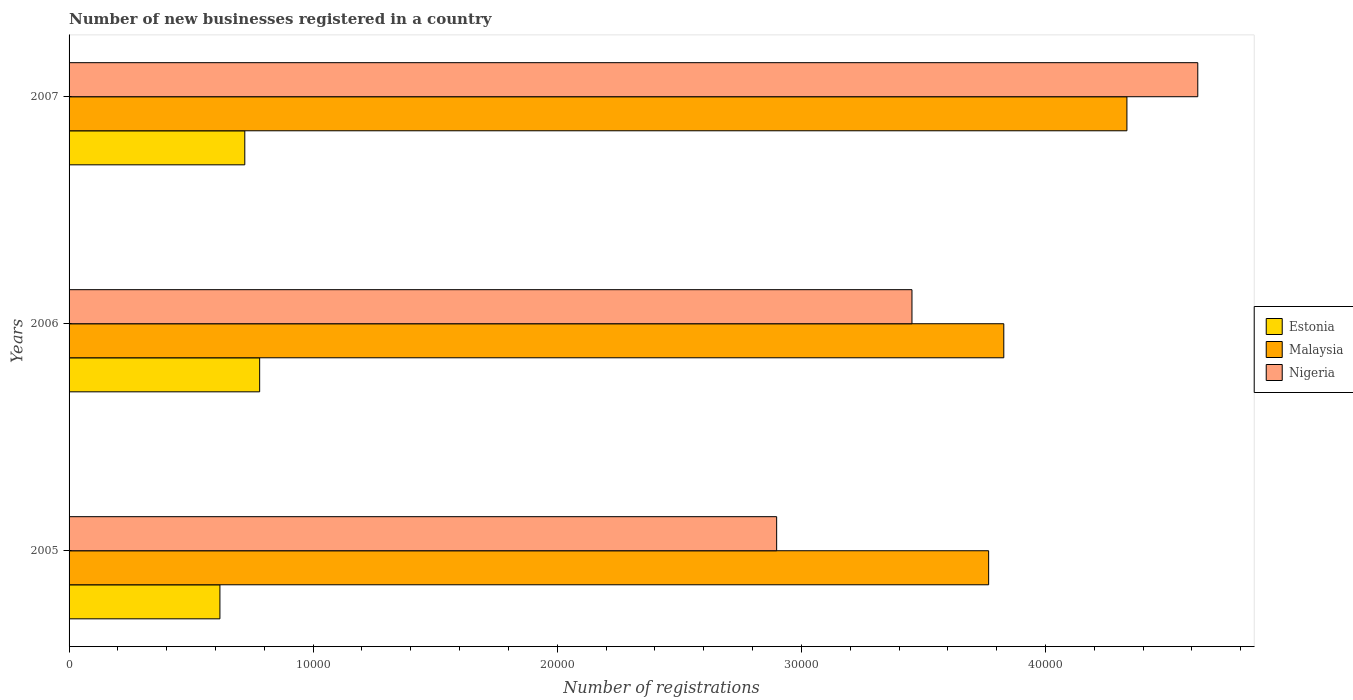What is the label of the 3rd group of bars from the top?
Your response must be concise. 2005. In how many cases, is the number of bars for a given year not equal to the number of legend labels?
Give a very brief answer. 0. What is the number of new businesses registered in Malaysia in 2005?
Offer a terse response. 3.77e+04. Across all years, what is the maximum number of new businesses registered in Nigeria?
Ensure brevity in your answer.  4.62e+04. Across all years, what is the minimum number of new businesses registered in Estonia?
Offer a very short reply. 6180. In which year was the number of new businesses registered in Estonia maximum?
Provide a short and direct response. 2006. In which year was the number of new businesses registered in Nigeria minimum?
Ensure brevity in your answer.  2005. What is the total number of new businesses registered in Estonia in the graph?
Ensure brevity in your answer.  2.12e+04. What is the difference between the number of new businesses registered in Malaysia in 2005 and that in 2007?
Ensure brevity in your answer.  -5665. What is the difference between the number of new businesses registered in Nigeria in 2006 and the number of new businesses registered in Estonia in 2005?
Your response must be concise. 2.84e+04. What is the average number of new businesses registered in Nigeria per year?
Provide a short and direct response. 3.66e+04. In the year 2006, what is the difference between the number of new businesses registered in Malaysia and number of new businesses registered in Estonia?
Give a very brief answer. 3.05e+04. In how many years, is the number of new businesses registered in Nigeria greater than 2000 ?
Offer a terse response. 3. What is the ratio of the number of new businesses registered in Estonia in 2005 to that in 2006?
Your answer should be very brief. 0.79. Is the difference between the number of new businesses registered in Malaysia in 2006 and 2007 greater than the difference between the number of new businesses registered in Estonia in 2006 and 2007?
Provide a succinct answer. No. What is the difference between the highest and the second highest number of new businesses registered in Malaysia?
Your answer should be very brief. 5044. What is the difference between the highest and the lowest number of new businesses registered in Malaysia?
Make the answer very short. 5665. What does the 3rd bar from the top in 2005 represents?
Provide a short and direct response. Estonia. What does the 3rd bar from the bottom in 2007 represents?
Your answer should be compact. Nigeria. What is the difference between two consecutive major ticks on the X-axis?
Offer a very short reply. 10000. Where does the legend appear in the graph?
Your answer should be very brief. Center right. What is the title of the graph?
Keep it short and to the point. Number of new businesses registered in a country. What is the label or title of the X-axis?
Your response must be concise. Number of registrations. What is the label or title of the Y-axis?
Your answer should be compact. Years. What is the Number of registrations of Estonia in 2005?
Your response must be concise. 6180. What is the Number of registrations in Malaysia in 2005?
Provide a succinct answer. 3.77e+04. What is the Number of registrations in Nigeria in 2005?
Keep it short and to the point. 2.90e+04. What is the Number of registrations in Estonia in 2006?
Provide a succinct answer. 7808. What is the Number of registrations of Malaysia in 2006?
Your answer should be very brief. 3.83e+04. What is the Number of registrations of Nigeria in 2006?
Offer a terse response. 3.45e+04. What is the Number of registrations in Estonia in 2007?
Provide a short and direct response. 7199. What is the Number of registrations of Malaysia in 2007?
Give a very brief answer. 4.33e+04. What is the Number of registrations of Nigeria in 2007?
Provide a succinct answer. 4.62e+04. Across all years, what is the maximum Number of registrations of Estonia?
Your response must be concise. 7808. Across all years, what is the maximum Number of registrations in Malaysia?
Offer a terse response. 4.33e+04. Across all years, what is the maximum Number of registrations in Nigeria?
Your answer should be compact. 4.62e+04. Across all years, what is the minimum Number of registrations of Estonia?
Offer a very short reply. 6180. Across all years, what is the minimum Number of registrations in Malaysia?
Ensure brevity in your answer.  3.77e+04. Across all years, what is the minimum Number of registrations in Nigeria?
Your answer should be compact. 2.90e+04. What is the total Number of registrations of Estonia in the graph?
Provide a short and direct response. 2.12e+04. What is the total Number of registrations in Malaysia in the graph?
Provide a short and direct response. 1.19e+05. What is the total Number of registrations in Nigeria in the graph?
Keep it short and to the point. 1.10e+05. What is the difference between the Number of registrations in Estonia in 2005 and that in 2006?
Make the answer very short. -1628. What is the difference between the Number of registrations of Malaysia in 2005 and that in 2006?
Provide a short and direct response. -621. What is the difference between the Number of registrations in Nigeria in 2005 and that in 2006?
Your response must be concise. -5543. What is the difference between the Number of registrations of Estonia in 2005 and that in 2007?
Your response must be concise. -1019. What is the difference between the Number of registrations of Malaysia in 2005 and that in 2007?
Ensure brevity in your answer.  -5665. What is the difference between the Number of registrations in Nigeria in 2005 and that in 2007?
Your answer should be compact. -1.73e+04. What is the difference between the Number of registrations of Estonia in 2006 and that in 2007?
Your response must be concise. 609. What is the difference between the Number of registrations of Malaysia in 2006 and that in 2007?
Provide a short and direct response. -5044. What is the difference between the Number of registrations of Nigeria in 2006 and that in 2007?
Give a very brief answer. -1.17e+04. What is the difference between the Number of registrations of Estonia in 2005 and the Number of registrations of Malaysia in 2006?
Ensure brevity in your answer.  -3.21e+04. What is the difference between the Number of registrations of Estonia in 2005 and the Number of registrations of Nigeria in 2006?
Provide a succinct answer. -2.84e+04. What is the difference between the Number of registrations in Malaysia in 2005 and the Number of registrations in Nigeria in 2006?
Your response must be concise. 3141. What is the difference between the Number of registrations of Estonia in 2005 and the Number of registrations of Malaysia in 2007?
Your answer should be very brief. -3.72e+04. What is the difference between the Number of registrations of Estonia in 2005 and the Number of registrations of Nigeria in 2007?
Provide a succinct answer. -4.01e+04. What is the difference between the Number of registrations of Malaysia in 2005 and the Number of registrations of Nigeria in 2007?
Provide a short and direct response. -8568. What is the difference between the Number of registrations of Estonia in 2006 and the Number of registrations of Malaysia in 2007?
Make the answer very short. -3.55e+04. What is the difference between the Number of registrations of Estonia in 2006 and the Number of registrations of Nigeria in 2007?
Offer a terse response. -3.84e+04. What is the difference between the Number of registrations in Malaysia in 2006 and the Number of registrations in Nigeria in 2007?
Provide a short and direct response. -7947. What is the average Number of registrations in Estonia per year?
Your answer should be very brief. 7062.33. What is the average Number of registrations of Malaysia per year?
Make the answer very short. 3.98e+04. What is the average Number of registrations in Nigeria per year?
Give a very brief answer. 3.66e+04. In the year 2005, what is the difference between the Number of registrations in Estonia and Number of registrations in Malaysia?
Make the answer very short. -3.15e+04. In the year 2005, what is the difference between the Number of registrations of Estonia and Number of registrations of Nigeria?
Offer a very short reply. -2.28e+04. In the year 2005, what is the difference between the Number of registrations of Malaysia and Number of registrations of Nigeria?
Make the answer very short. 8684. In the year 2006, what is the difference between the Number of registrations in Estonia and Number of registrations in Malaysia?
Keep it short and to the point. -3.05e+04. In the year 2006, what is the difference between the Number of registrations in Estonia and Number of registrations in Nigeria?
Ensure brevity in your answer.  -2.67e+04. In the year 2006, what is the difference between the Number of registrations of Malaysia and Number of registrations of Nigeria?
Your answer should be compact. 3762. In the year 2007, what is the difference between the Number of registrations in Estonia and Number of registrations in Malaysia?
Offer a very short reply. -3.61e+04. In the year 2007, what is the difference between the Number of registrations in Estonia and Number of registrations in Nigeria?
Your answer should be very brief. -3.90e+04. In the year 2007, what is the difference between the Number of registrations in Malaysia and Number of registrations in Nigeria?
Give a very brief answer. -2903. What is the ratio of the Number of registrations of Estonia in 2005 to that in 2006?
Make the answer very short. 0.79. What is the ratio of the Number of registrations in Malaysia in 2005 to that in 2006?
Offer a very short reply. 0.98. What is the ratio of the Number of registrations in Nigeria in 2005 to that in 2006?
Offer a terse response. 0.84. What is the ratio of the Number of registrations of Estonia in 2005 to that in 2007?
Give a very brief answer. 0.86. What is the ratio of the Number of registrations in Malaysia in 2005 to that in 2007?
Provide a short and direct response. 0.87. What is the ratio of the Number of registrations of Nigeria in 2005 to that in 2007?
Provide a short and direct response. 0.63. What is the ratio of the Number of registrations of Estonia in 2006 to that in 2007?
Offer a terse response. 1.08. What is the ratio of the Number of registrations in Malaysia in 2006 to that in 2007?
Provide a succinct answer. 0.88. What is the ratio of the Number of registrations of Nigeria in 2006 to that in 2007?
Provide a succinct answer. 0.75. What is the difference between the highest and the second highest Number of registrations of Estonia?
Your answer should be very brief. 609. What is the difference between the highest and the second highest Number of registrations in Malaysia?
Make the answer very short. 5044. What is the difference between the highest and the second highest Number of registrations in Nigeria?
Provide a short and direct response. 1.17e+04. What is the difference between the highest and the lowest Number of registrations in Estonia?
Offer a terse response. 1628. What is the difference between the highest and the lowest Number of registrations of Malaysia?
Give a very brief answer. 5665. What is the difference between the highest and the lowest Number of registrations in Nigeria?
Ensure brevity in your answer.  1.73e+04. 